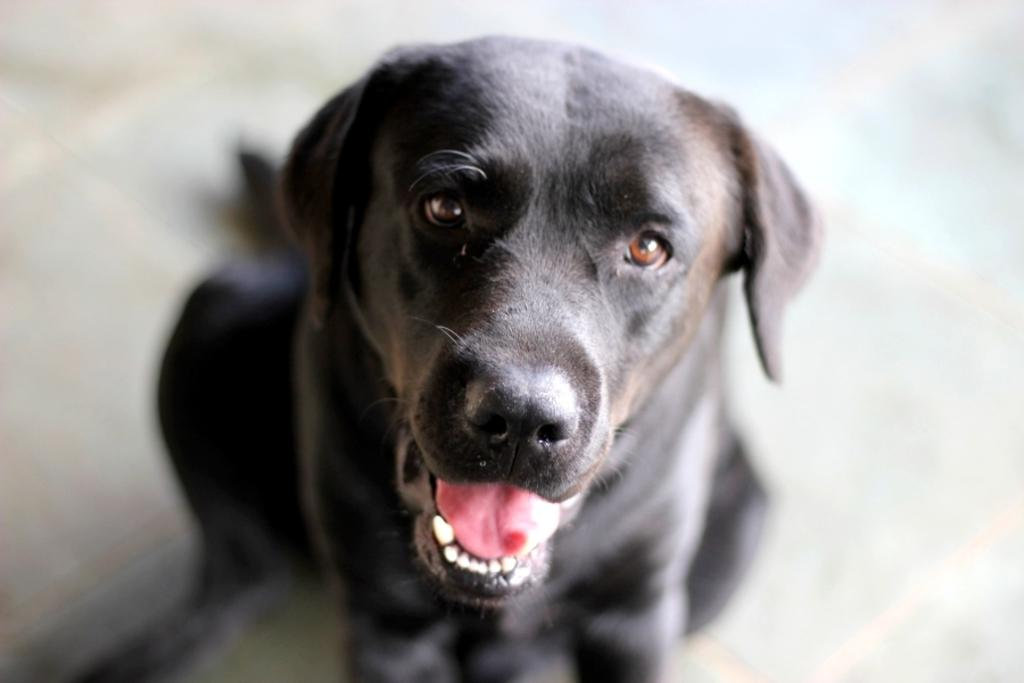What type of animal is in the image? There is a black color dog in the image. What is the dog doing in the image? The dog is sitting in the front. Can you describe the background of the image? The background of the image is blurry. What type of floor can be seen in the image? There is no specific floor visible in the image, as the focus is on the dog and the background is blurry. 